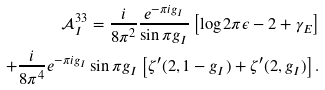Convert formula to latex. <formula><loc_0><loc_0><loc_500><loc_500>\mathcal { A } ^ { 3 3 } _ { I } = \frac { i } { 8 \pi ^ { 2 } } \frac { e ^ { - \pi i g _ { I } } } { \sin \pi g _ { I } } \left [ \log 2 \pi \epsilon - 2 + \gamma _ { E } \right ] \\ + \frac { i } { 8 \pi ^ { 4 } } e ^ { - \pi i g _ { I } } \sin \pi g _ { I } \left [ \zeta ^ { \prime } ( 2 , 1 - g _ { I } ) + \zeta ^ { \prime } ( 2 , g _ { I } ) \right ] .</formula> 